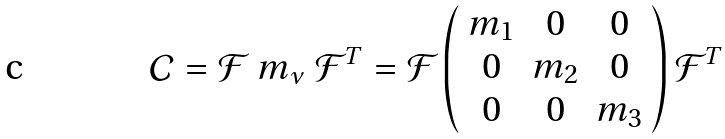<formula> <loc_0><loc_0><loc_500><loc_500>\mathcal { C } = \mathcal { F } \ m _ { \nu } \ \mathcal { F } ^ { T } = \mathcal { F } \left ( \begin{array} { * { 3 } { c } } m _ { 1 } & 0 & 0 \\ 0 & m _ { 2 } & 0 \\ 0 & 0 & m _ { 3 } \\ \end{array} \right ) \mathcal { F } ^ { T }</formula> 